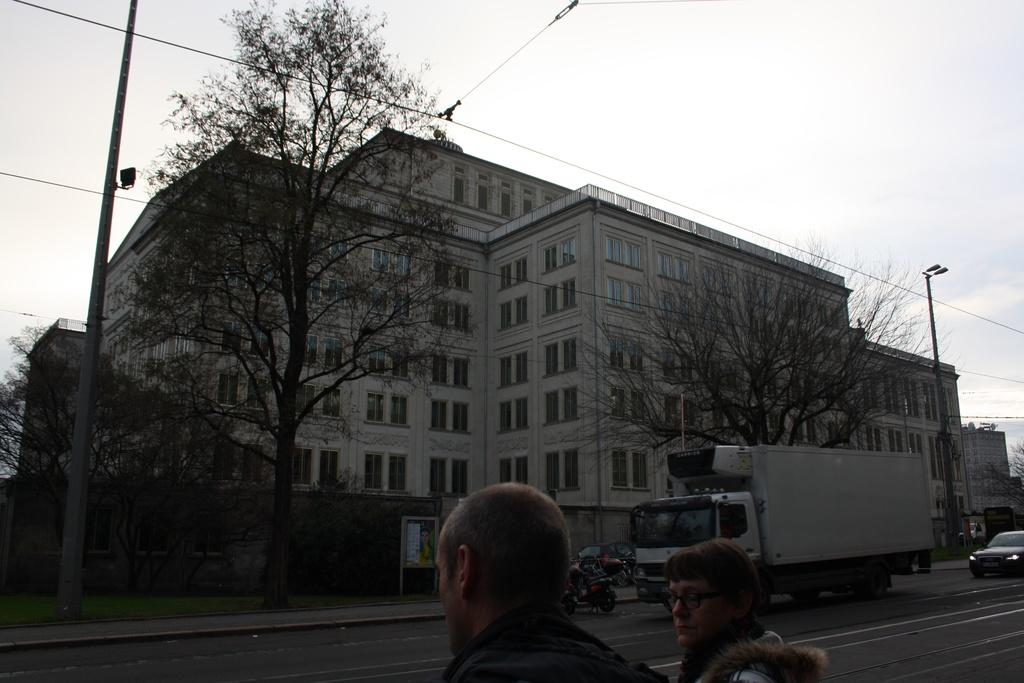What can be seen in the sky in the image? The sky is visible in the image. What type of infrastructure is present in the image? Electric poles and electric cables are present in the image. What type of structures can be seen in the image? There are buildings in the image. What type of vegetation is visible in the image? Trees are visible in the image. What type of commercial elements are present in the image? Advertisement boards are present in the image. What type of transportation is visible in the image? Motor vehicles are on the road in the image. Are there any people present in the image? Yes, there are persons in the image. Can you tell me how many crayons the girl is holding in the image? There is no girl present in the image, and therefore no crayons can be observed. What type of servant is present in the image? There is no servant present in the image. 